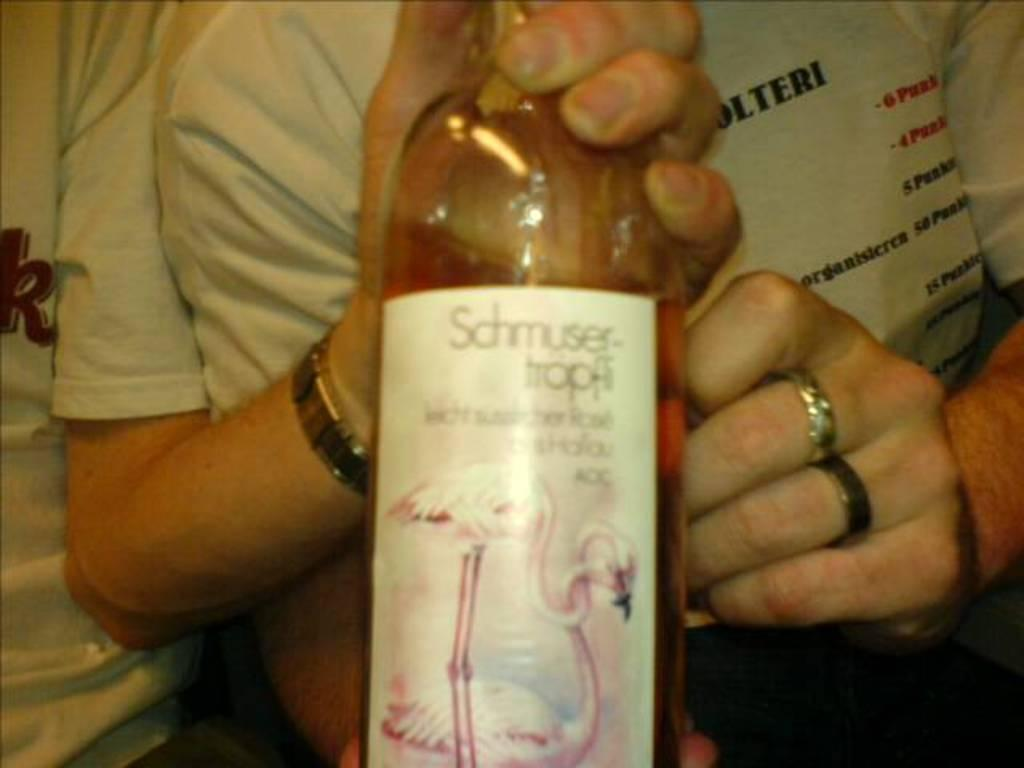How many people are in the image? There are two persons in the image. What are the two persons doing in the image? The two persons are standing together. Can you describe what one of the persons is holding? One person is holding a bottle in their hand. What type of food is being cooked in the oven in the image? There is no oven or food present in the image. What type of cookware is being used by the person holding the bottle? The image does not show any cookware being used by the person holding the bottle. 